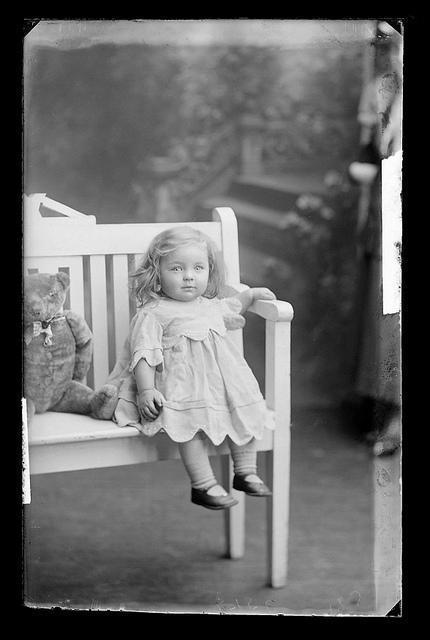How many benches are there?
Give a very brief answer. 1. 